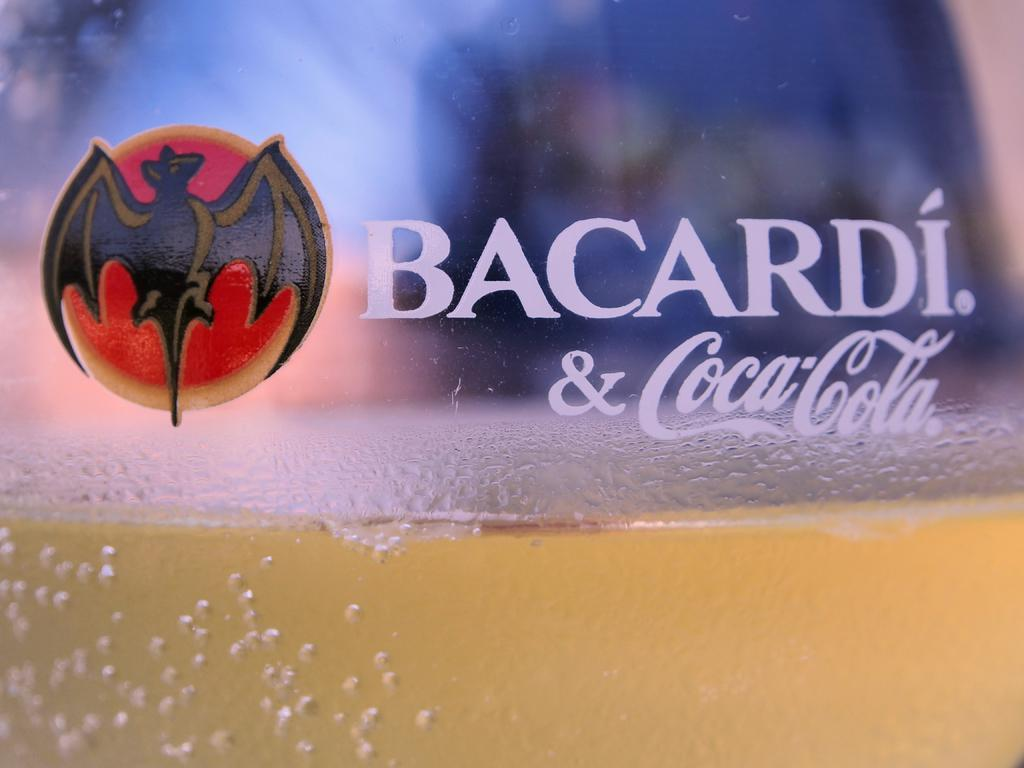Provide a one-sentence caption for the provided image. A glass half full labeled with Bacardi and Coca Cola. 